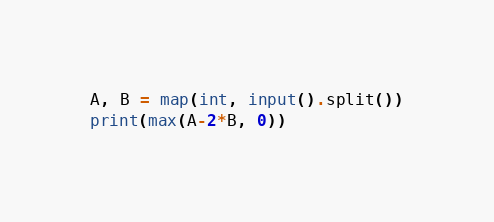<code> <loc_0><loc_0><loc_500><loc_500><_Python_>A, B = map(int, input().split())
print(max(A-2*B, 0))</code> 